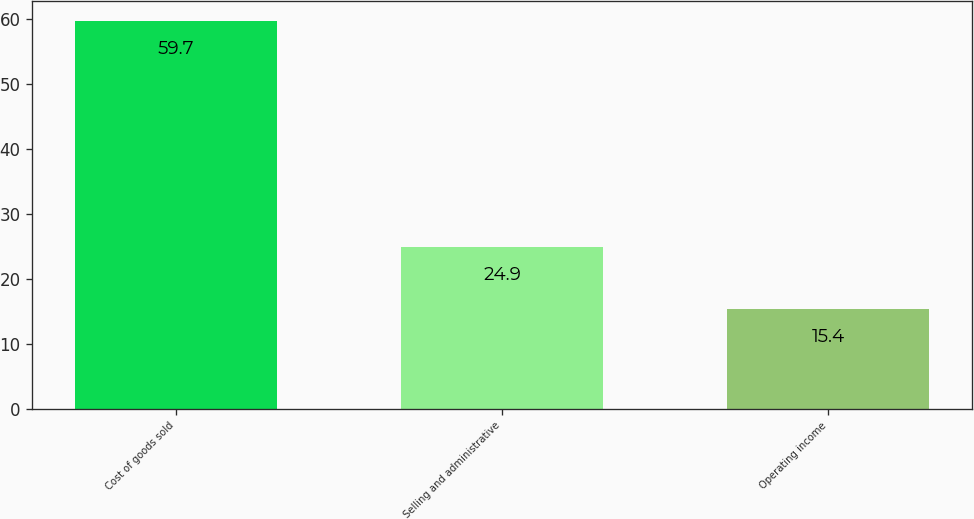Convert chart to OTSL. <chart><loc_0><loc_0><loc_500><loc_500><bar_chart><fcel>Cost of goods sold<fcel>Selling and administrative<fcel>Operating income<nl><fcel>59.7<fcel>24.9<fcel>15.4<nl></chart> 